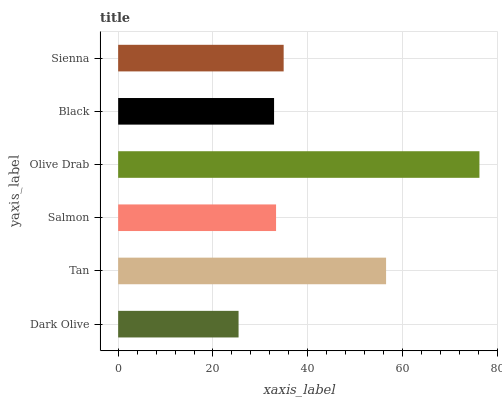Is Dark Olive the minimum?
Answer yes or no. Yes. Is Olive Drab the maximum?
Answer yes or no. Yes. Is Tan the minimum?
Answer yes or no. No. Is Tan the maximum?
Answer yes or no. No. Is Tan greater than Dark Olive?
Answer yes or no. Yes. Is Dark Olive less than Tan?
Answer yes or no. Yes. Is Dark Olive greater than Tan?
Answer yes or no. No. Is Tan less than Dark Olive?
Answer yes or no. No. Is Sienna the high median?
Answer yes or no. Yes. Is Salmon the low median?
Answer yes or no. Yes. Is Olive Drab the high median?
Answer yes or no. No. Is Sienna the low median?
Answer yes or no. No. 